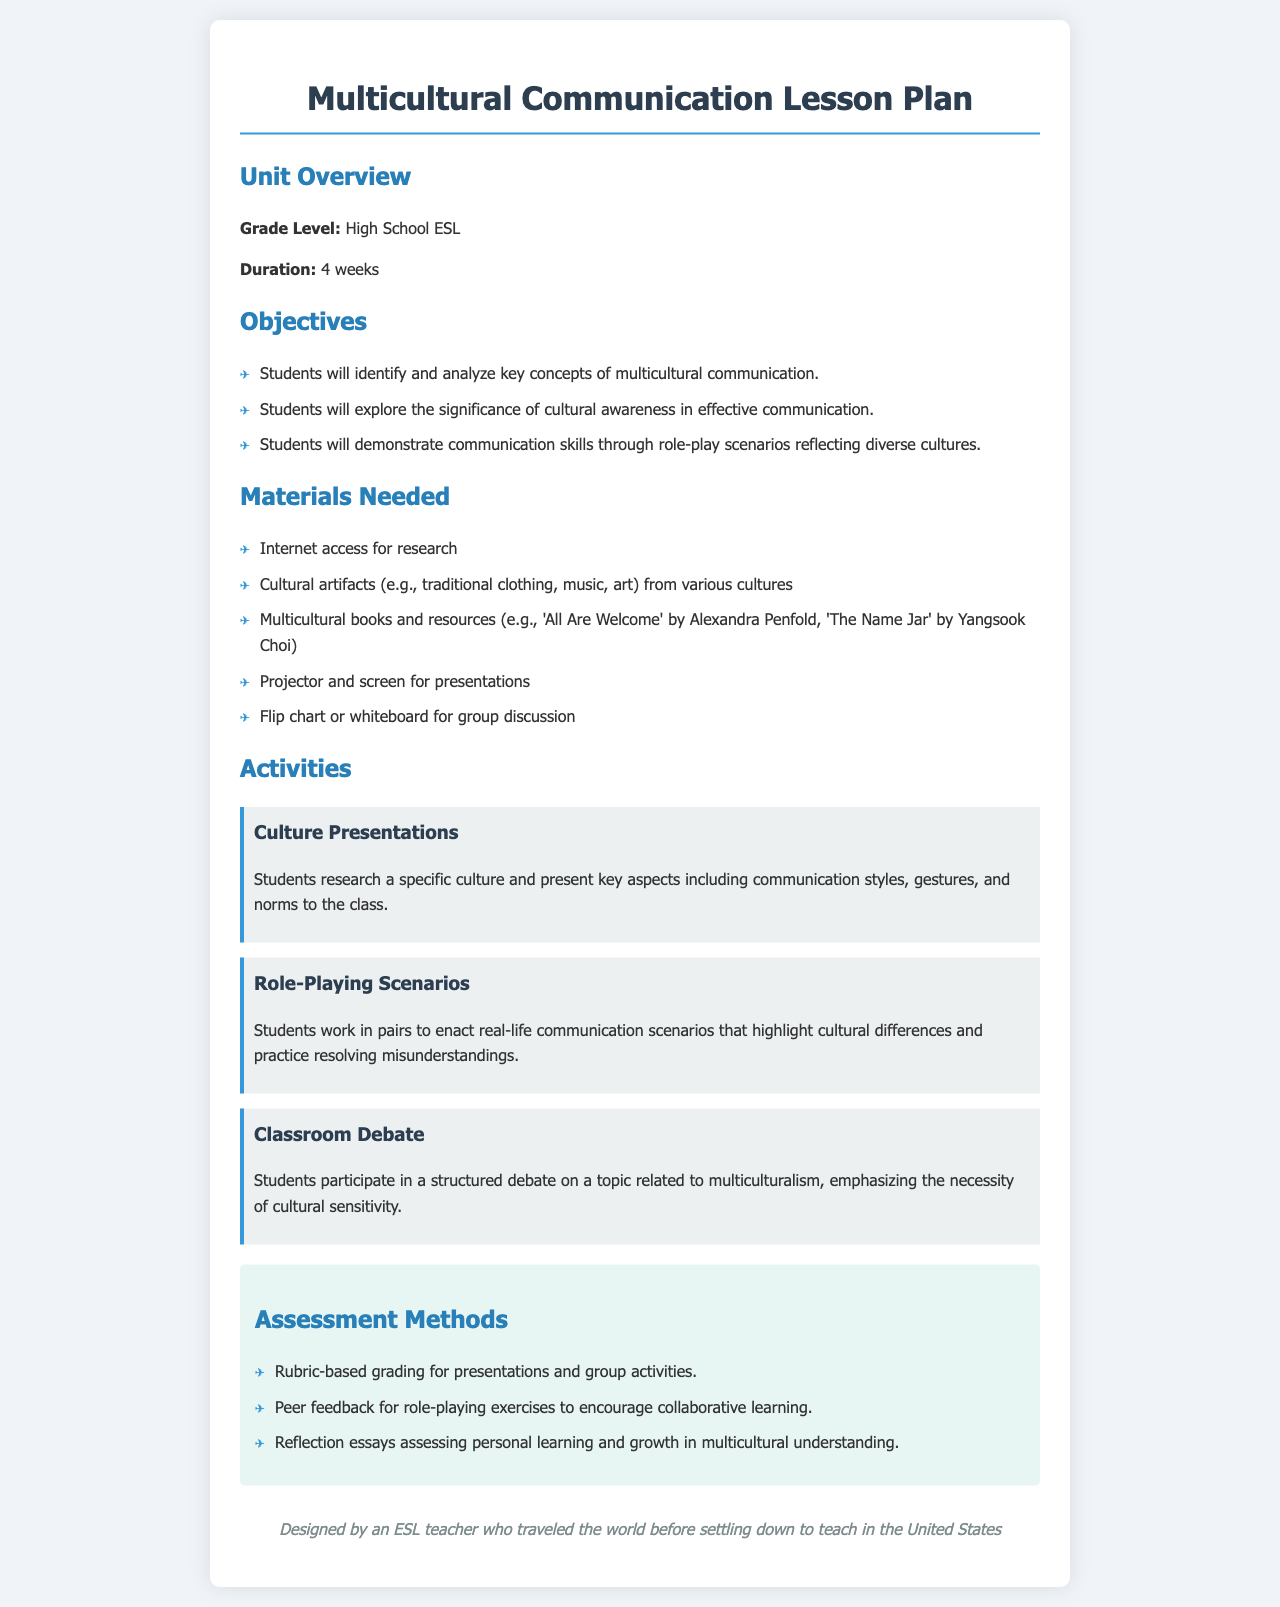What is the grade level for the unit? The document specifies that the grade level for the unit is High School ESL.
Answer: High School ESL How long is the unit designed to last? The document states that the duration of the unit is 4 weeks.
Answer: 4 weeks Name one cultural artifact mentioned in the materials needed. The document lists cultural artifacts, examples being traditional clothing, music, or art from various cultures.
Answer: Traditional clothing What is one of the objectives related to communication skills? The document outlines that students will demonstrate communication skills through role-play scenarios.
Answer: Role-play scenarios How are presentations graded? The assessment portion of the document states that presentations are graded using a rubric.
Answer: Rubric-based grading What type of essays will students write for assessment? The document indicates that students will write reflection essays assessing personal learning.
Answer: Reflection essays What activity involves researching a specific culture? The document describes an activity called "Culture Presentations" in which students research a specific culture.
Answer: Culture Presentations What method encourages collaborative learning in role-playing exercises? The document mentions that peer feedback is used to encourage collaborative learning in role-playing exercises.
Answer: Peer feedback 